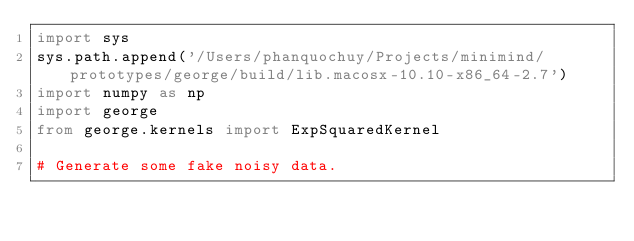Convert code to text. <code><loc_0><loc_0><loc_500><loc_500><_Python_>import sys
sys.path.append('/Users/phanquochuy/Projects/minimind/prototypes/george/build/lib.macosx-10.10-x86_64-2.7')
import numpy as np
import george
from george.kernels import ExpSquaredKernel

# Generate some fake noisy data.</code> 